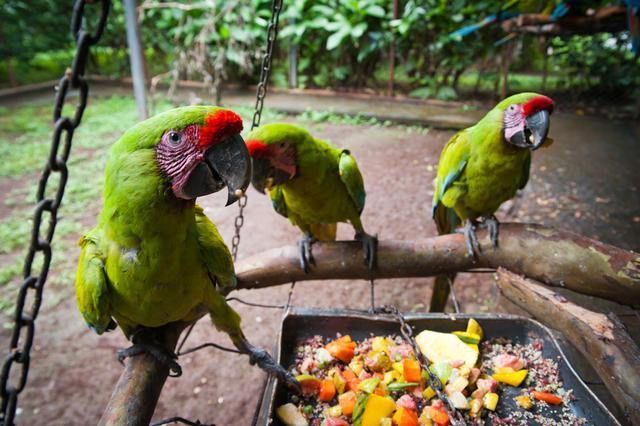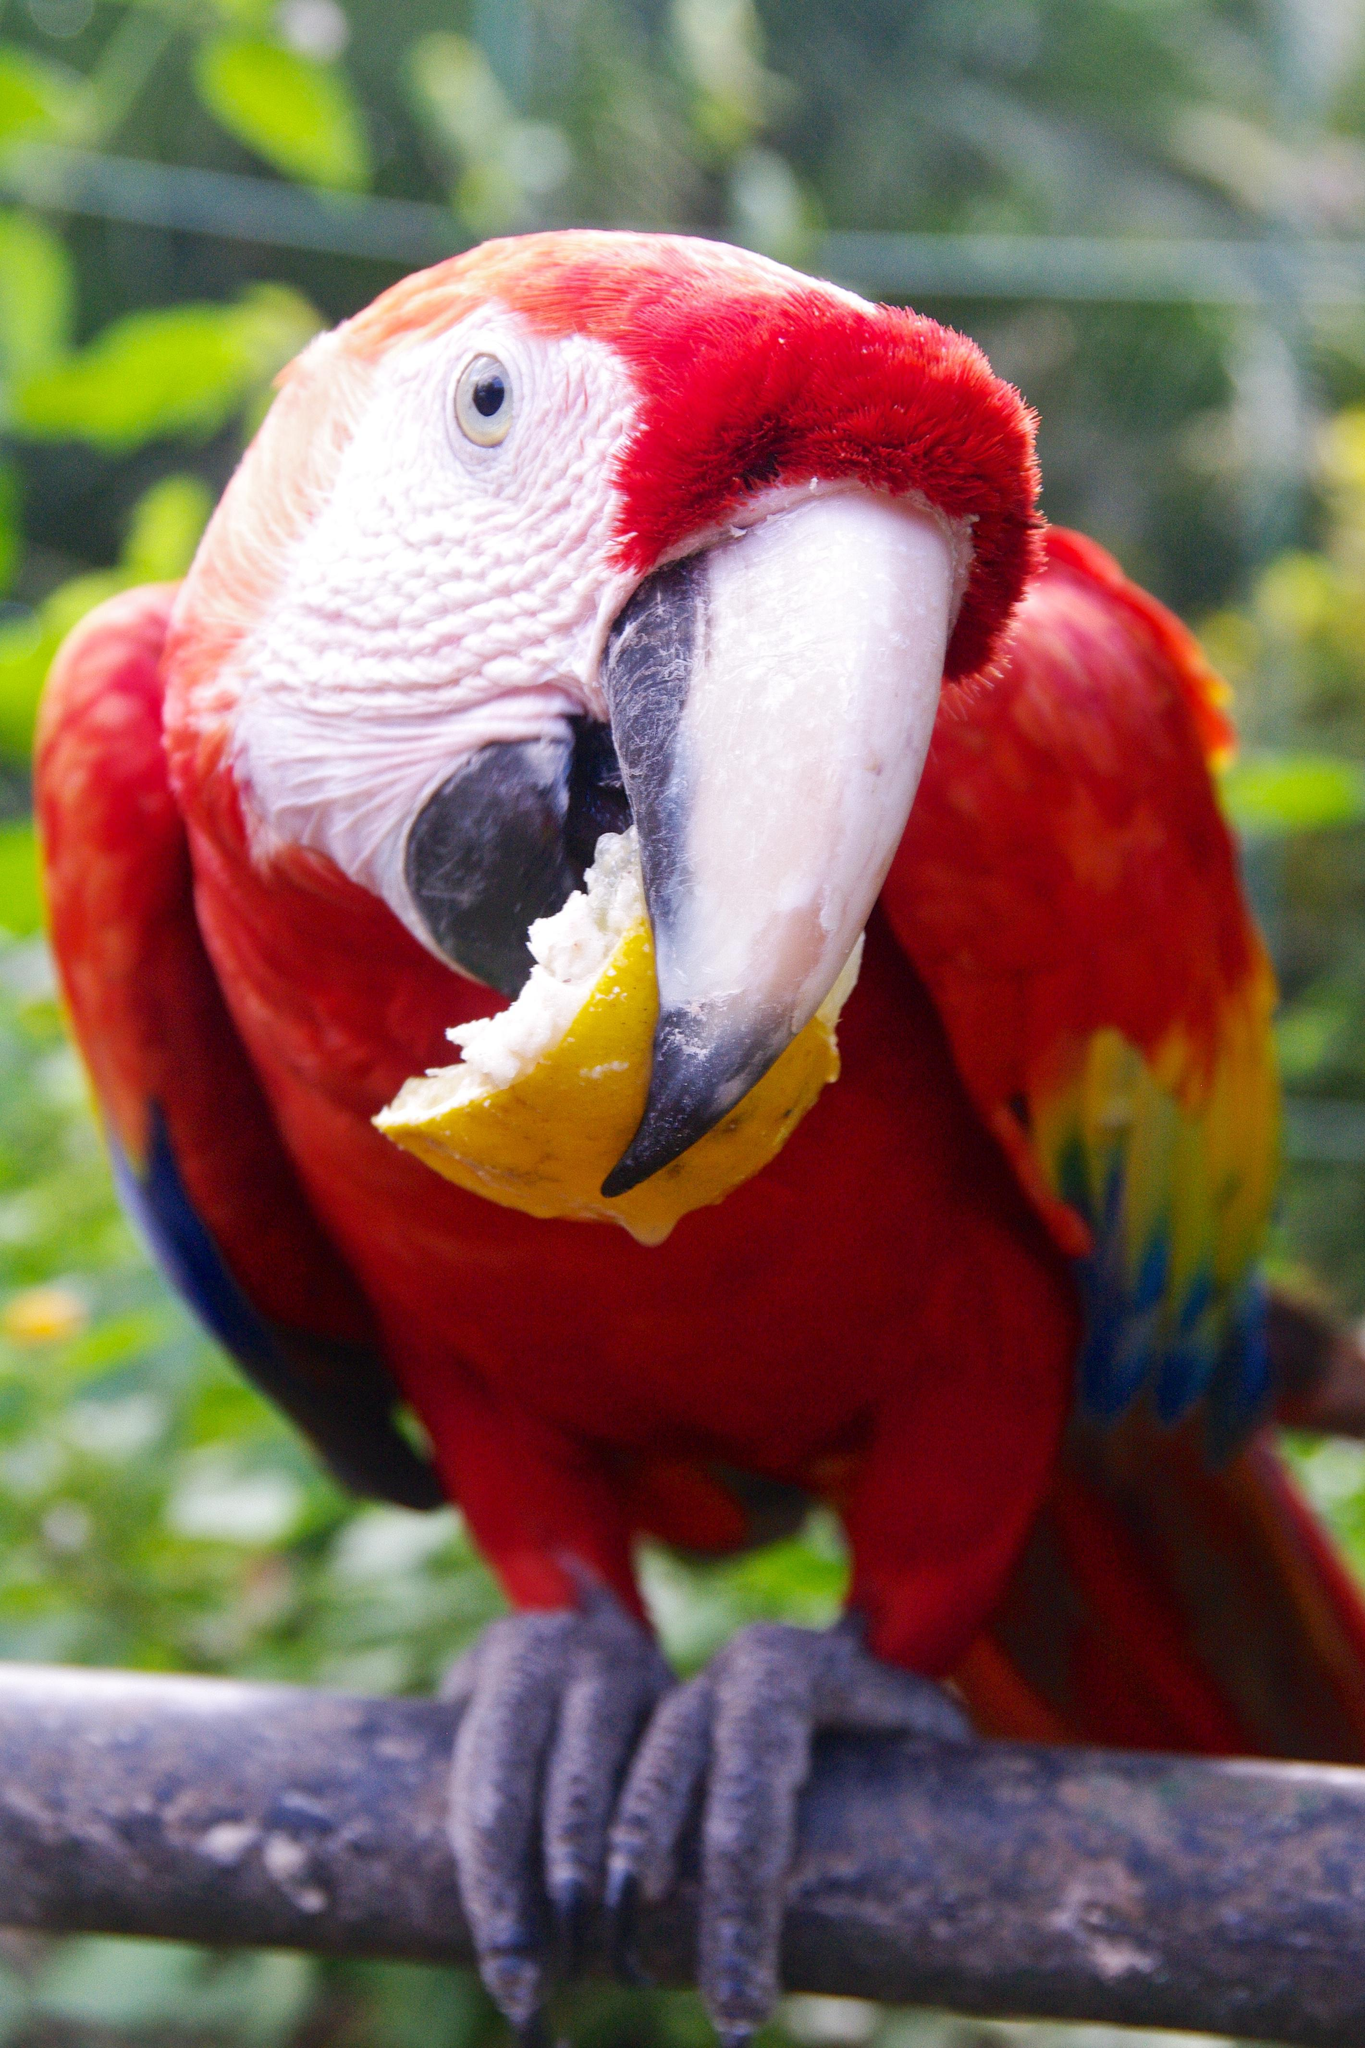The first image is the image on the left, the second image is the image on the right. Evaluate the accuracy of this statement regarding the images: "The right image contains no more than one parrot.". Is it true? Answer yes or no. Yes. 